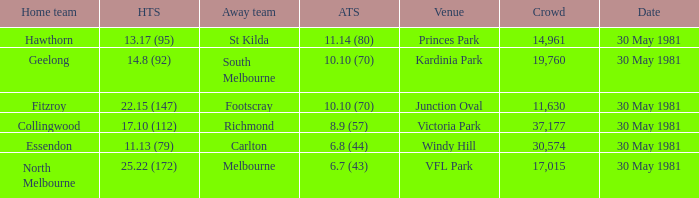What team played away at vfl park? Melbourne. 